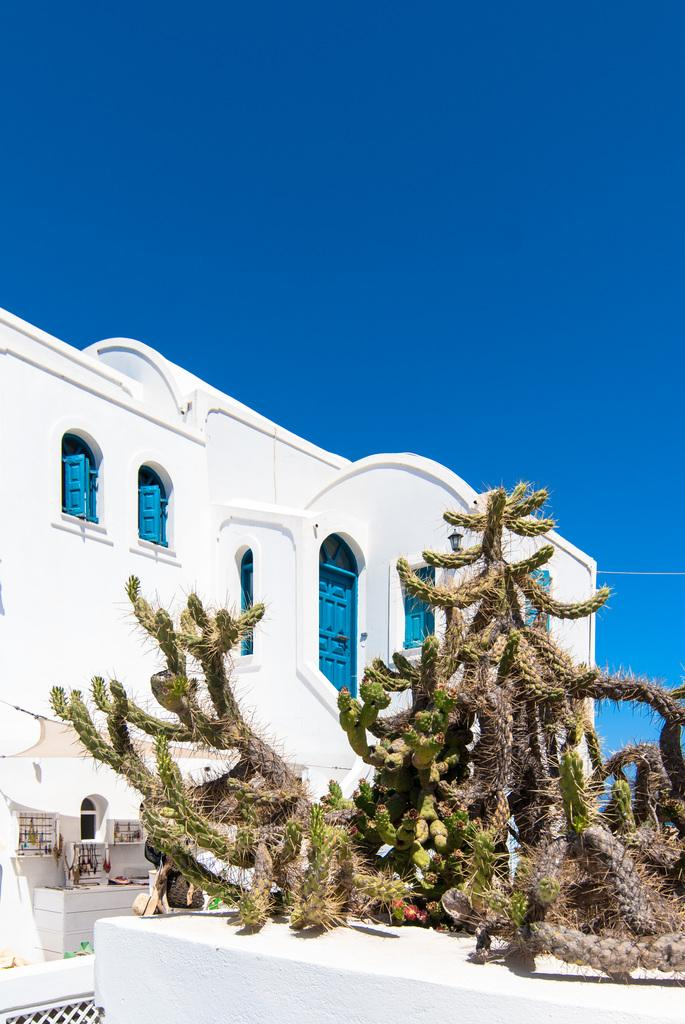What type of structure is visible in the image? There is a house in the image. Can you describe any decorative elements in the image? There is a plant placed on the wall in the image. How many ladybugs can be seen crawling on the foot in the image? There are no ladybugs or feet present in the image. 